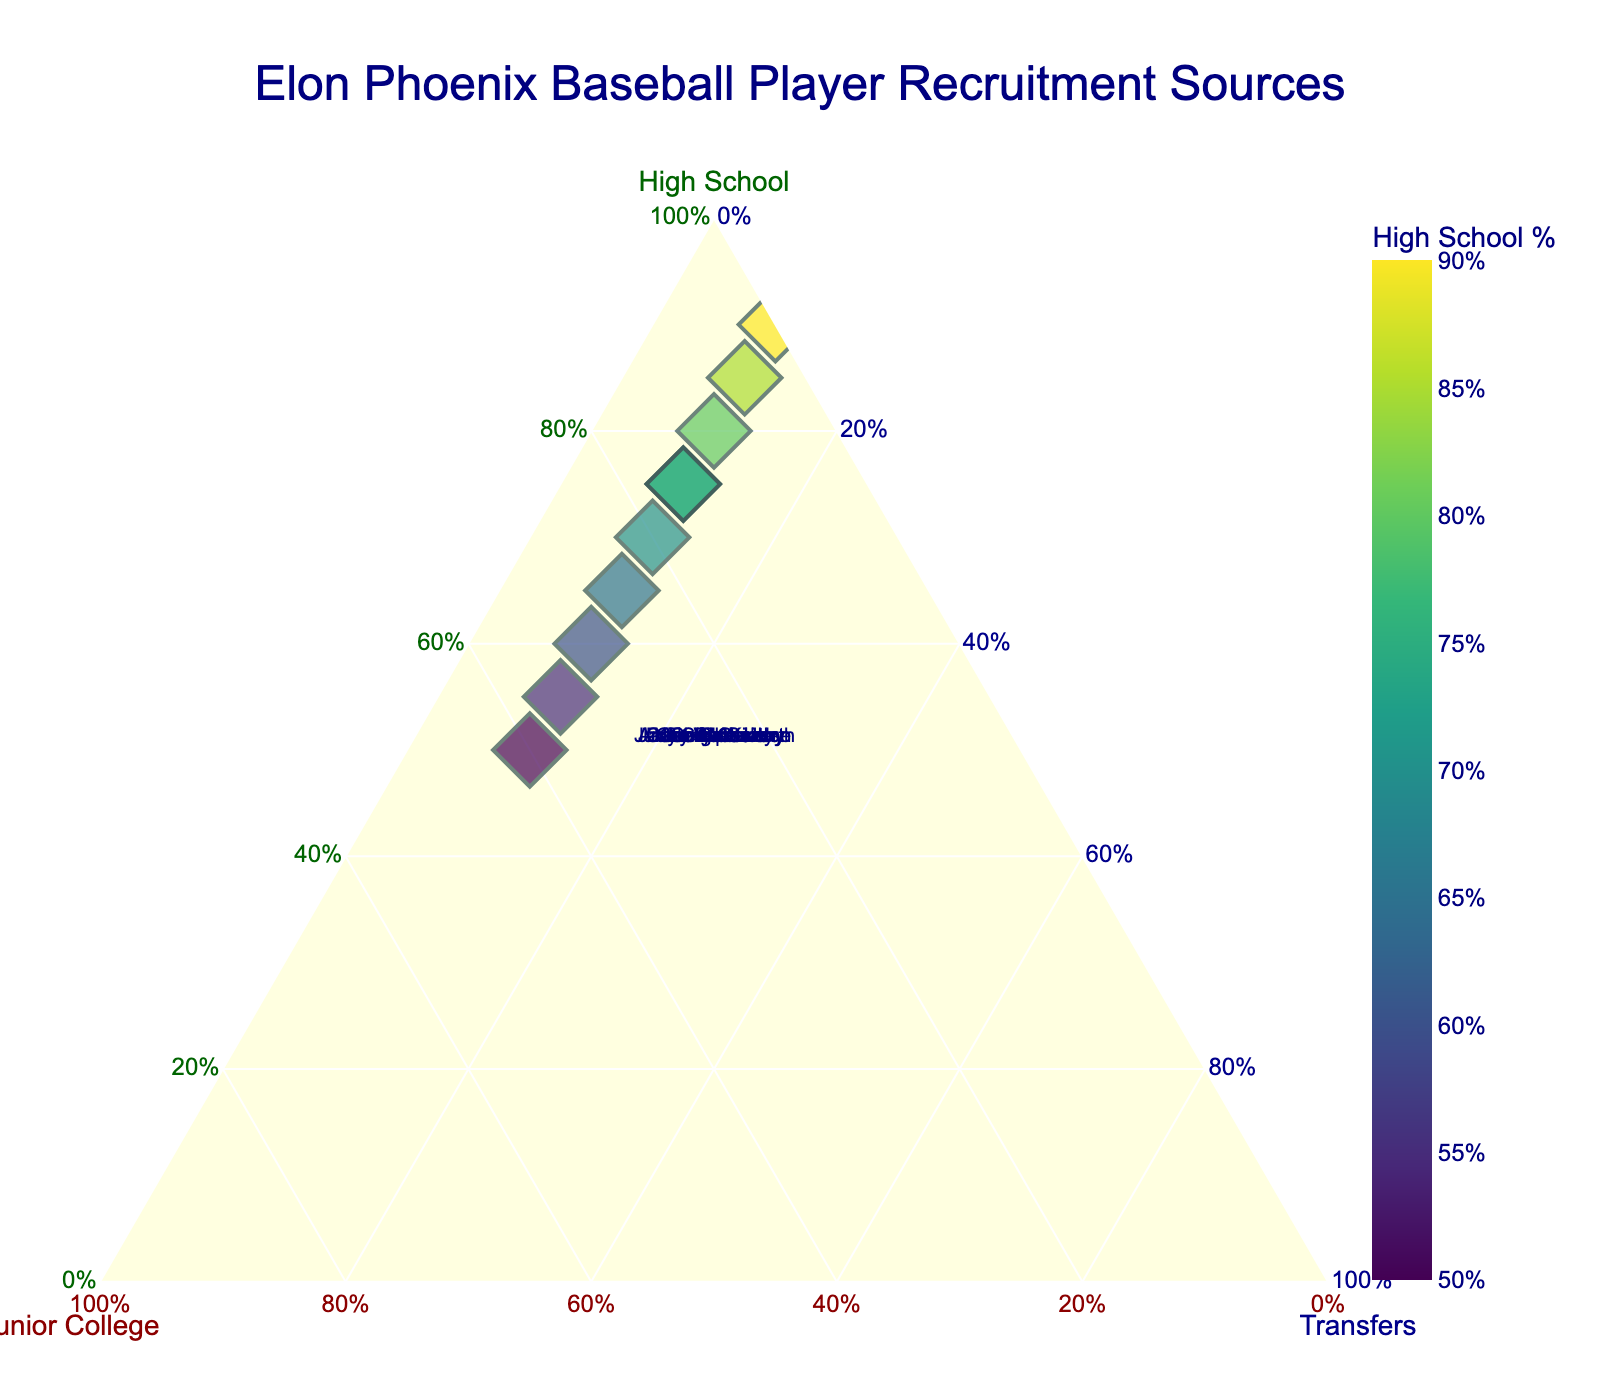What is the title of the figure? The title is displayed at the top of the figure. It directly states what the figure is about.
Answer: Elon Phoenix Baseball Player Recruitment Sources How many players were recruited primarily from high school? By looking at the points positioned closer to the 'High School' axis (or having a higher 'High School' percentage), we identify those recruits. Players like George Kirby, Cam Devanney, Ty Adcock, and others fit this category. Count these specific players.
Answer: 10 What color represents the players recruited mainly from high school? The color coding indicates different 'High School' percentages. The colors range from the Viridis color scale shown on the legend for 'High School %,' where higher percentages are darker shades of green.
Answer: Dark green Which player has the highest percentage from Junior College? Check the position closest to the 'Junior College' axis. Higher values mean being situated more towards that axis. Dean McCarthy has the highest 'Junior College' recruitment percentage at 0.40.
Answer: Dean McCarthy Who stands out with 0% Junior College recruitment? Look for a point positioned on the 'Transfers-High School' edge, indicating no contribution from 'Junior College.' George Kirby has 0% 'Junior College'.
Answer: George Kirby If you add the percentages of High School and Transfers for Joe Sprake, what is the result? For Joe Sprake, the percentages are 0.55 (High School) and 0.10 (Transfers). Adding these yields 0.55 + 0.10 = 0.65.
Answer: 0.65 Compare the 'Junior College' percentages of Cole Aker and Jared Wetherbee. Who has a higher percentage? Both players are assessed by their position closer to the 'Junior College' axis. Cole Aker has a 0.30, while Jared Wetherbee has a 0.20 Junior College percentage. Cole Aker has a higher percentage.
Answer: Cole Aker What percentage range from High School are most players recruited from? Observe the spread along the 'High School' axis. Most players lie between the 50% to 90% range, showing the majority recruitment percentages.
Answer: 50% to 90% Which axis has the least variation in player recruitment percentages? Compare the spread along each axis. The 'Transfers' axis shows all players tightly clustered around 0.10, indicating the least variation.
Answer: Transfers What is the average High School recruitment percentage for all players? Sum the High School percentages for all players and divide by the number of players. (0.75+0.60+0.80+0.70+0.55+0.65+0.85+0.50+0.75+0.90) / 10 = 7.05 / 10 = 0.705
Answer: 0.705 